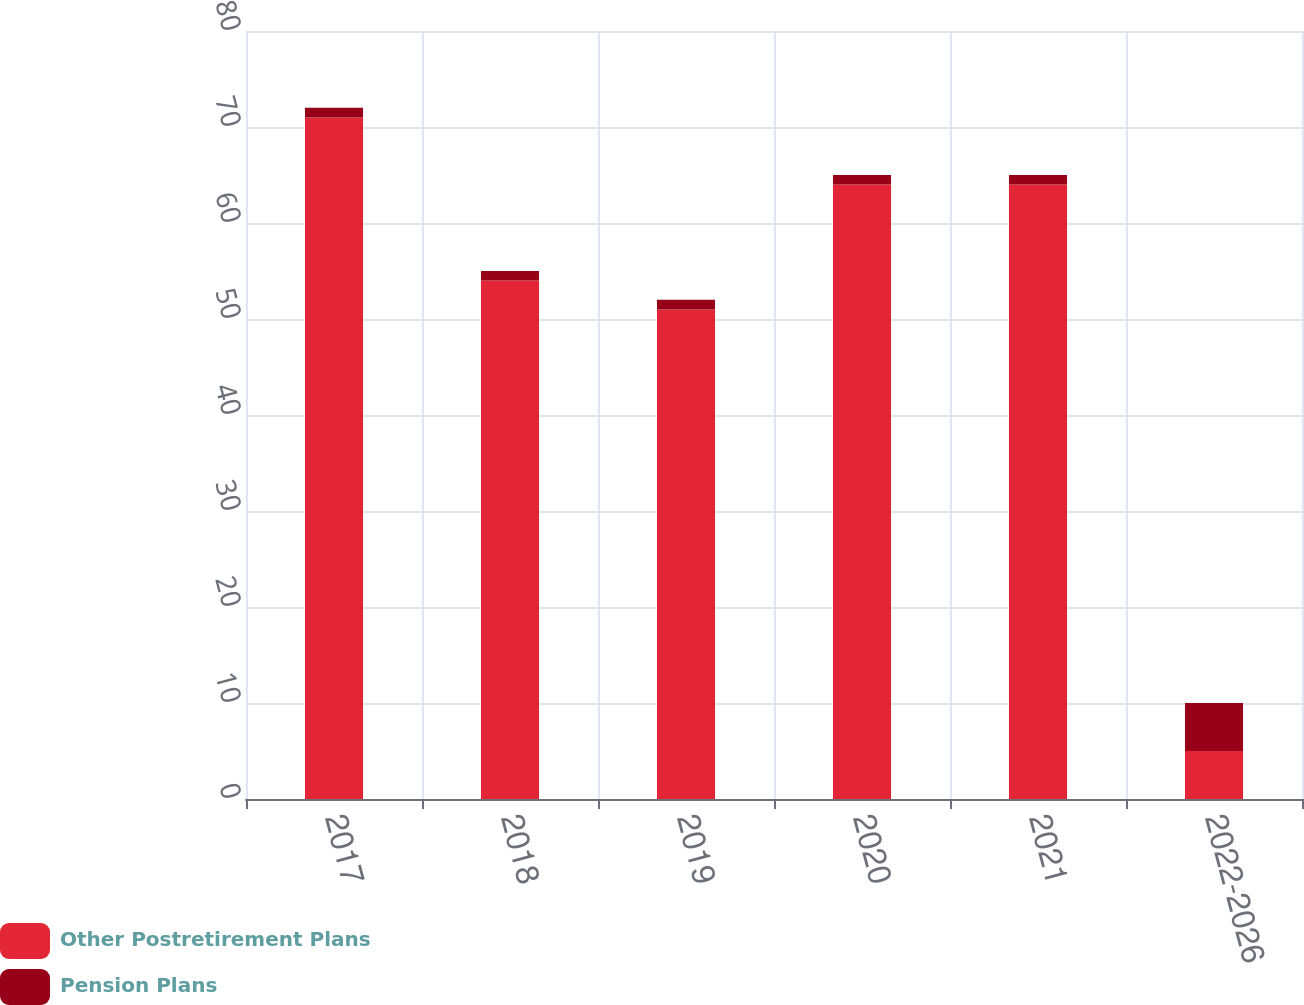Convert chart to OTSL. <chart><loc_0><loc_0><loc_500><loc_500><stacked_bar_chart><ecel><fcel>2017<fcel>2018<fcel>2019<fcel>2020<fcel>2021<fcel>2022-2026<nl><fcel>Other Postretirement Plans<fcel>71<fcel>54<fcel>51<fcel>64<fcel>64<fcel>5<nl><fcel>Pension Plans<fcel>1<fcel>1<fcel>1<fcel>1<fcel>1<fcel>5<nl></chart> 